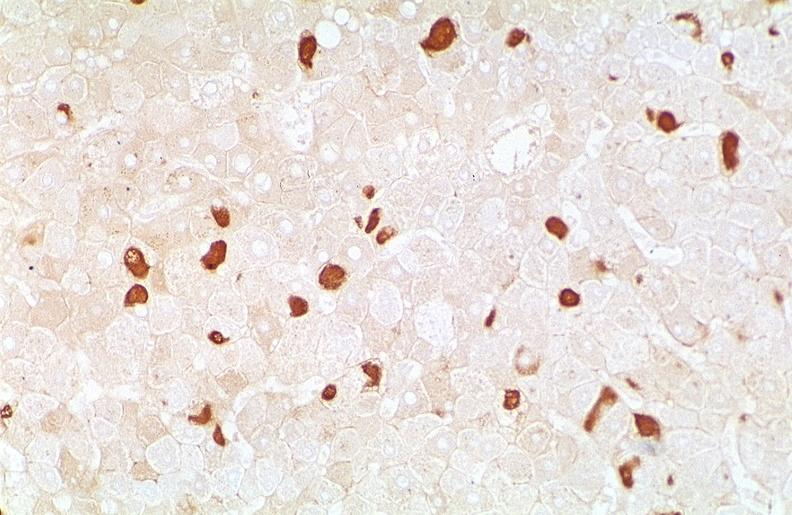s metastatic carcinoma oat cell present?
Answer the question using a single word or phrase. No 